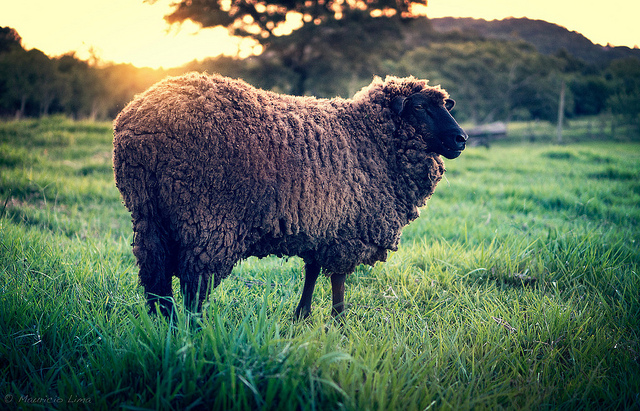What other animals might you expect to find in this kind of environment? In this tranquil, grassy field, you might find other farm animals such as cows, goats, or even horses. It’s an ideal setting for grazing, so these animals would likely be roaming around, enjoying the fresh grass and open space. 